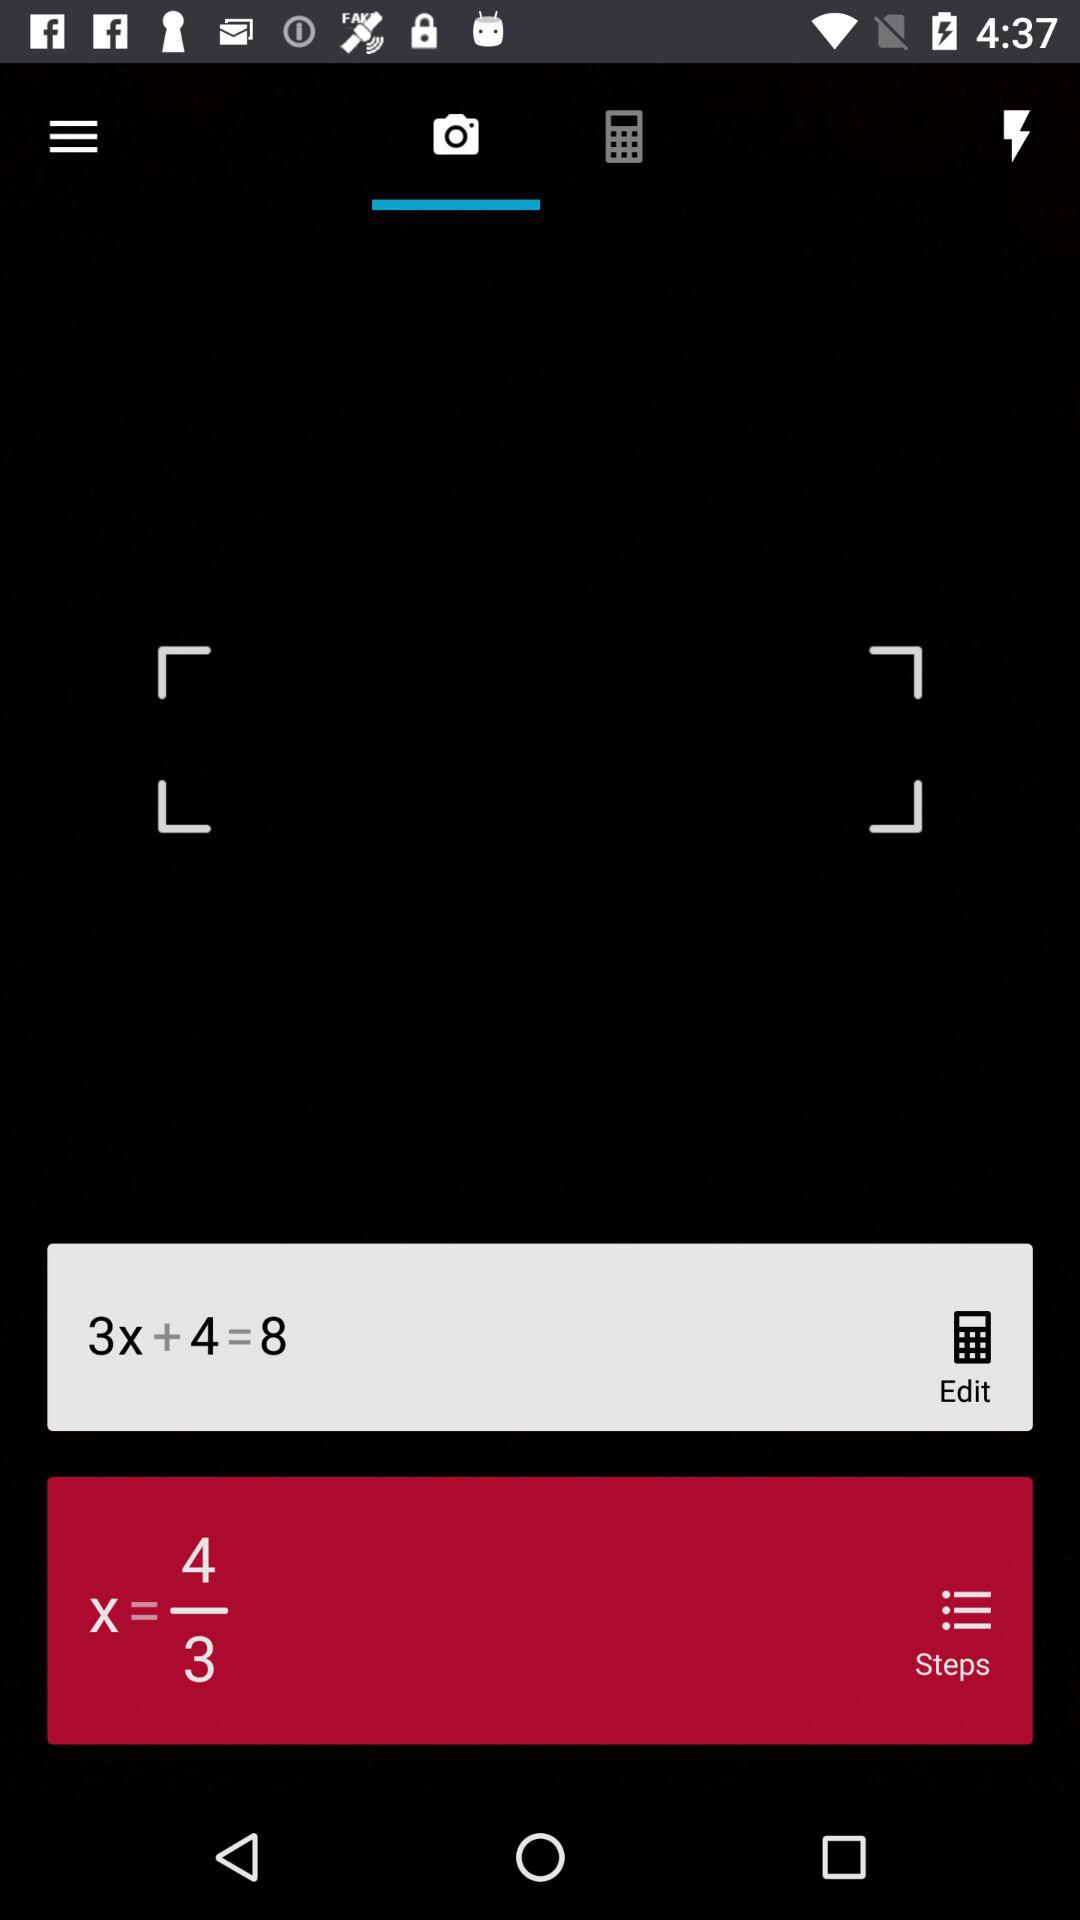What is the expression shown in the edit window? The expression is (3x + 4 = 8). 